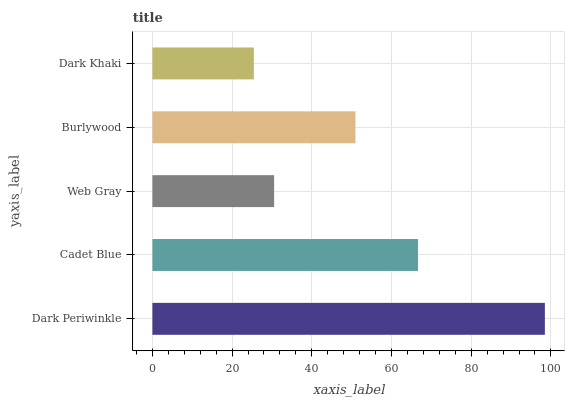Is Dark Khaki the minimum?
Answer yes or no. Yes. Is Dark Periwinkle the maximum?
Answer yes or no. Yes. Is Cadet Blue the minimum?
Answer yes or no. No. Is Cadet Blue the maximum?
Answer yes or no. No. Is Dark Periwinkle greater than Cadet Blue?
Answer yes or no. Yes. Is Cadet Blue less than Dark Periwinkle?
Answer yes or no. Yes. Is Cadet Blue greater than Dark Periwinkle?
Answer yes or no. No. Is Dark Periwinkle less than Cadet Blue?
Answer yes or no. No. Is Burlywood the high median?
Answer yes or no. Yes. Is Burlywood the low median?
Answer yes or no. Yes. Is Dark Periwinkle the high median?
Answer yes or no. No. Is Dark Periwinkle the low median?
Answer yes or no. No. 